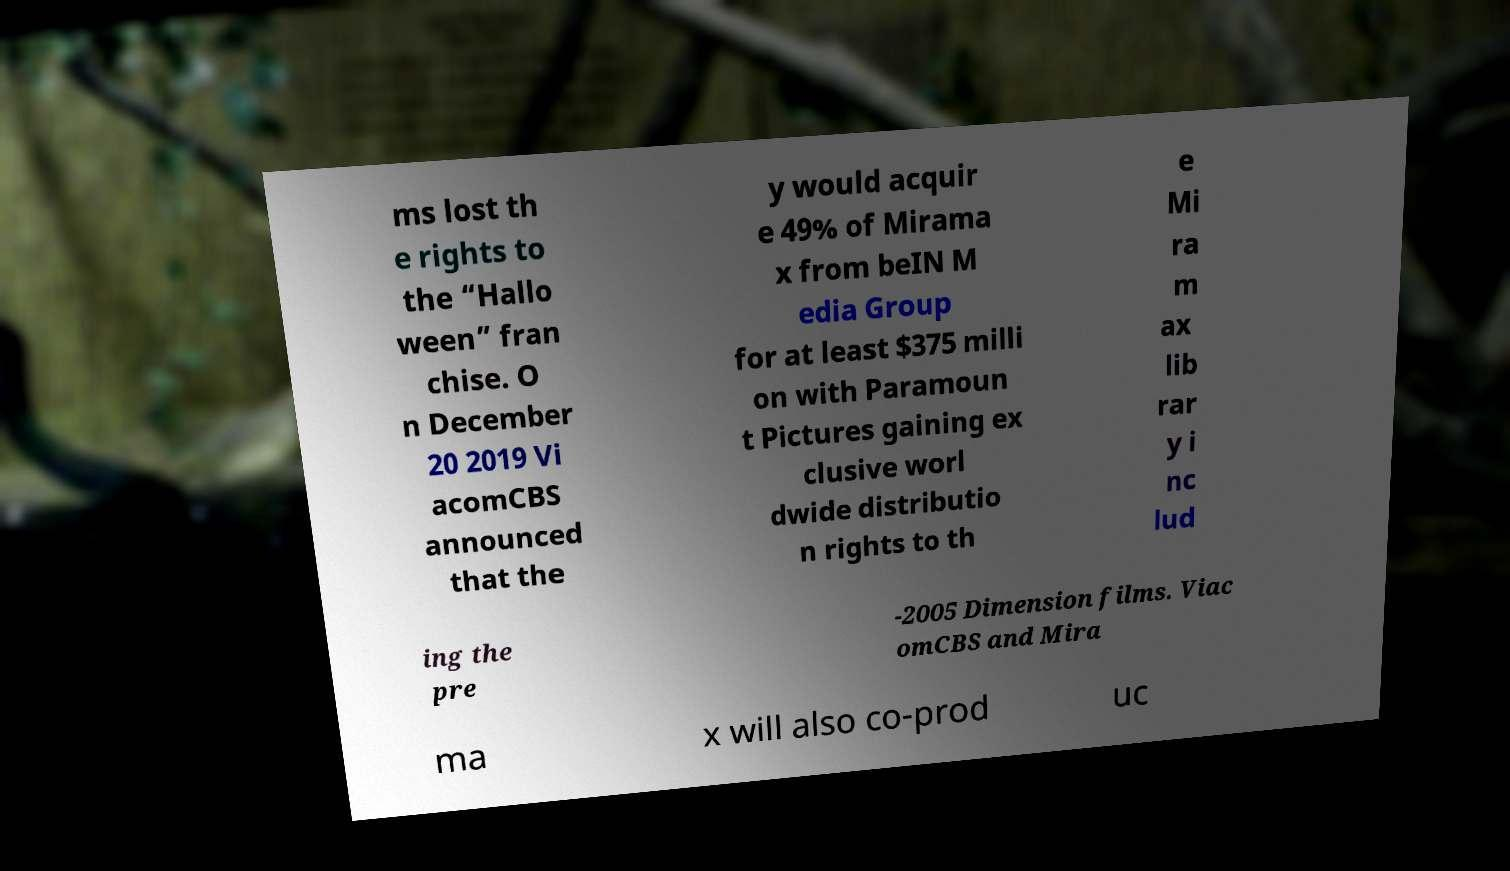Could you extract and type out the text from this image? ms lost th e rights to the “Hallo ween” fran chise. O n December 20 2019 Vi acomCBS announced that the y would acquir e 49% of Mirama x from beIN M edia Group for at least $375 milli on with Paramoun t Pictures gaining ex clusive worl dwide distributio n rights to th e Mi ra m ax lib rar y i nc lud ing the pre -2005 Dimension films. Viac omCBS and Mira ma x will also co-prod uc 